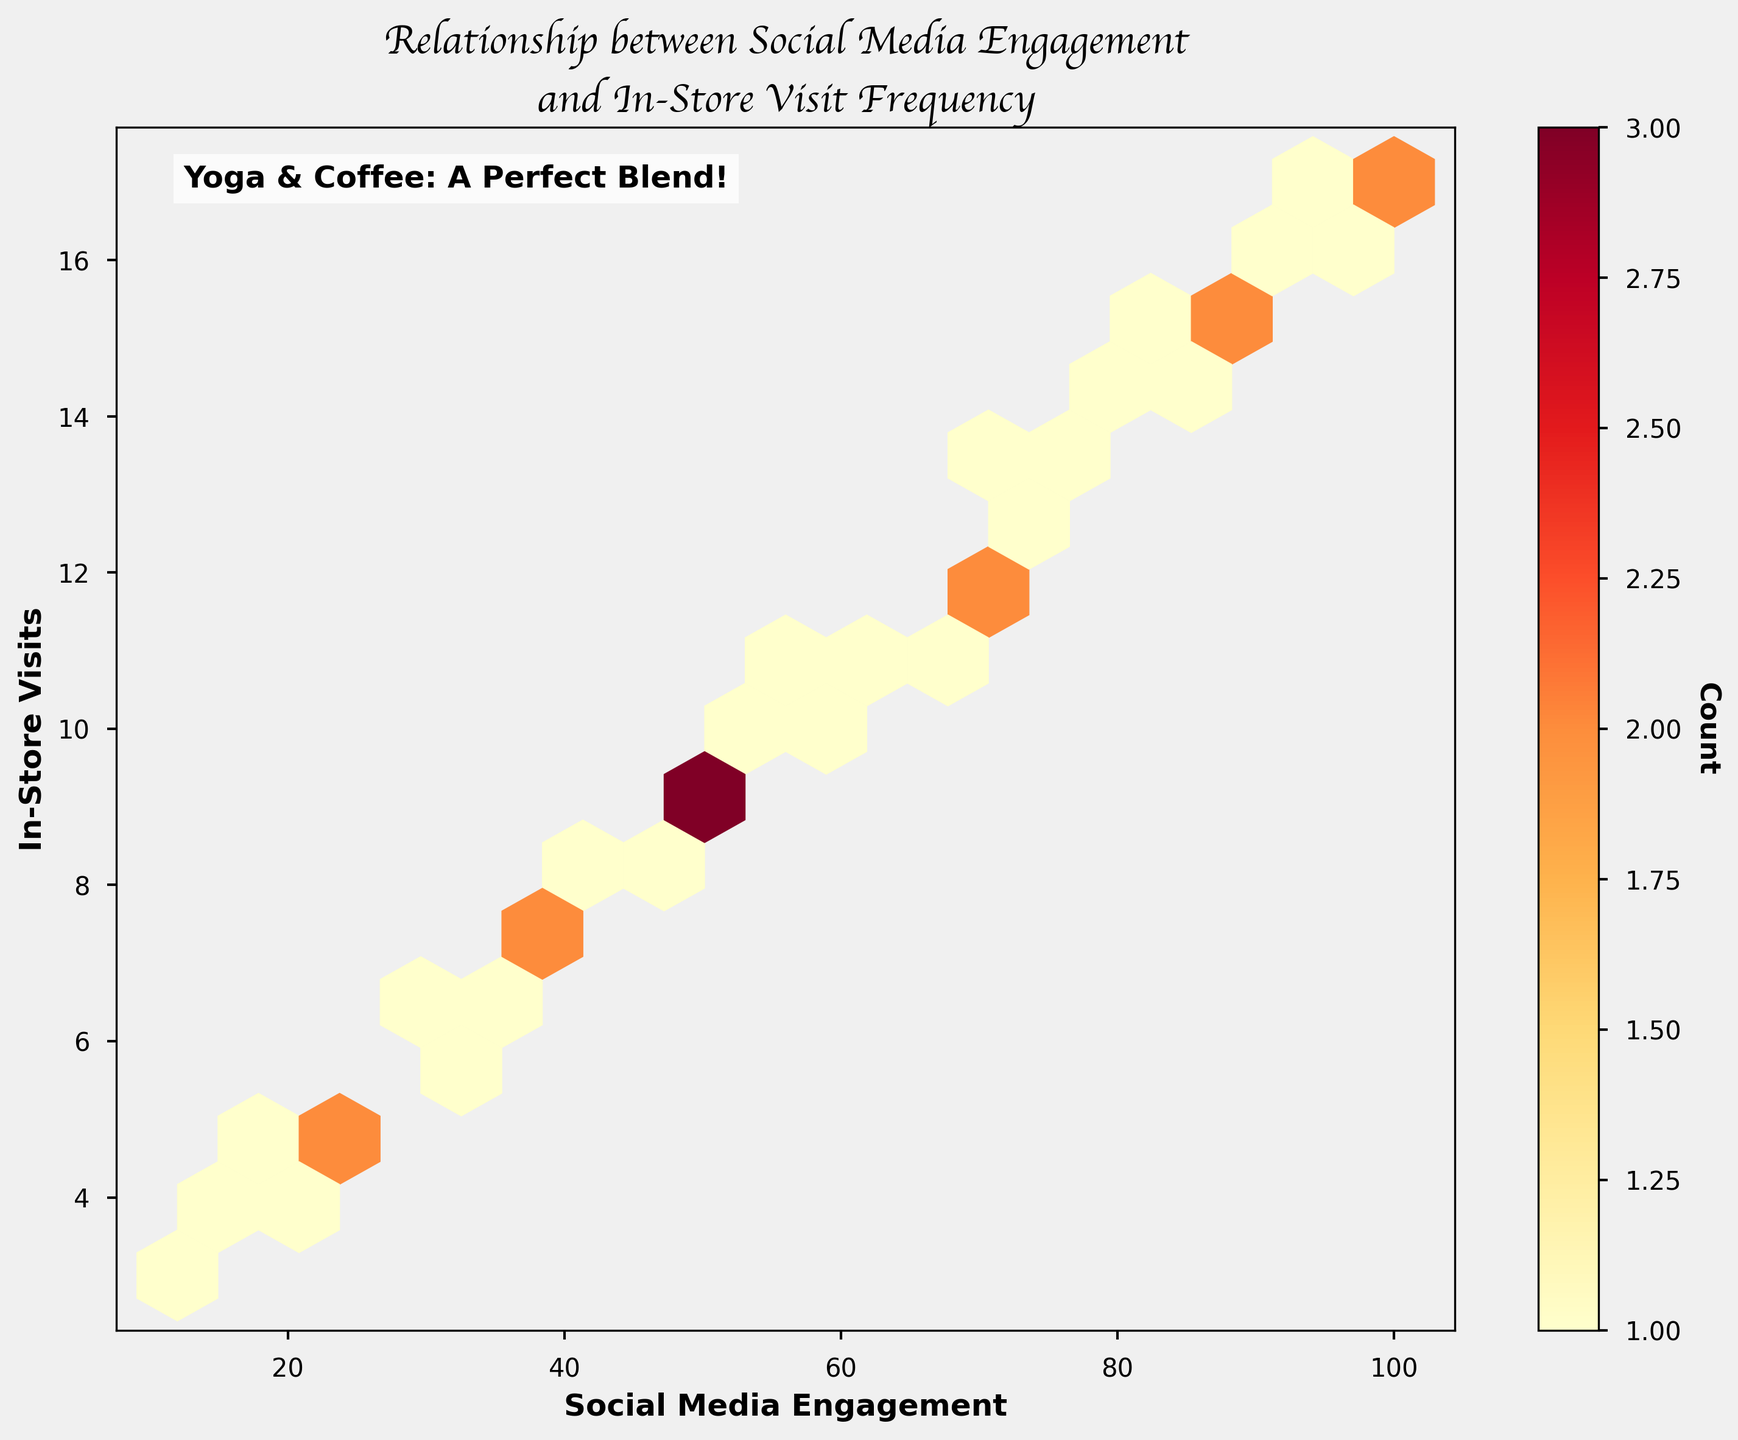What is the title of the plot? Look at the top of the plot to find the main heading. The title typically provides an overview of the contents or purpose of the plot.
Answer: Relationship between Social Media Engagement and In-Store Visit Frequency What are the labels for the x and y axes? The labels for the axes can be found along the respective sides of the plot, typically as text describing what each axis represents. The x-axis label is 'Social Media Engagement', and the y-axis label is 'In-Store Visits'.
Answer: Social Media Engagement and In-Store Visits What does the color intensity in the plot represent? Observe the color bar to the right of the plot, which shows the relationship between color intensity and the count of data points within each hexbin.
Answer: Count of data points Which social media engagement value has the highest frequency of in-store visits? Identify the darkest hexbin and trace back to the x-axis to determine the corresponding social media engagement value.
Answer: 50-60 What is the general trend shown in the plot between social media engagement and in-store visits? Analyze the overall distribution of the hexbin plot to determine whether there is an increasing or decreasing trend as one variable changes relative to the other.
Answer: Increasing trend What is the range of social media engagement values shown in the plot? Observe the start and end points on the x-axis to determine the minimum and maximum values of social media engagement.
Answer: 12 to 100 Do higher social media engagement values correspond to higher in-store visit frequencies? Look at the distribution of hexagons for higher x-values and see if there are corresponding higher y-values, indicating a pattern.
Answer: Yes What could be inferred about the success of promoting yoga sessions in attracting customers based on this plot? Considering the plot shows an increasing trend between social media engagement and in-store visits, it suggests that higher engagement through promotions like yoga sessions correlates with higher visit frequencies.
Answer: Higher social media engagement attracts more customers Is there any association between yoga promotions and in-store visits? Since the figure shows a positive correlation between social media engagement and in-store visits, it can be inferred that yoga promotions through social media might be effective.
Answer: Yes What's the color of the annotation text and its content inside the plot? The color and content of the annotation can be found by observing the text within the plot. The text says 'Yoga & Coffee: A Perfect Blend!' with a white background.
Answer: White, 'Yoga & Coffee: A Perfect Blend!' 